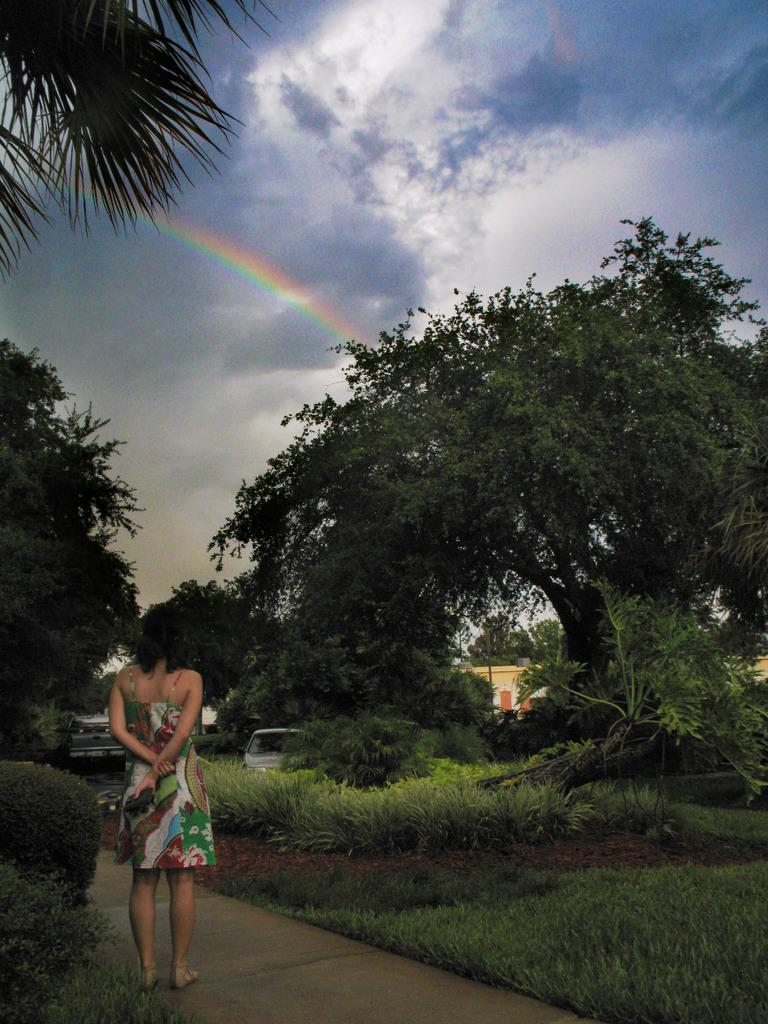What is the woman doing in the image? The woman is standing on a path in the image. What type of natural elements can be seen in the image? Trees are present in the image. What else can be seen in the image besides the woman and trees? Vehicles and a building are visible in the image. What is visible in the background of the image? The sky with clouds is visible in the background of the image. How many ants can be seen carrying a badge in the image? There are no ants or badges present in the image. 